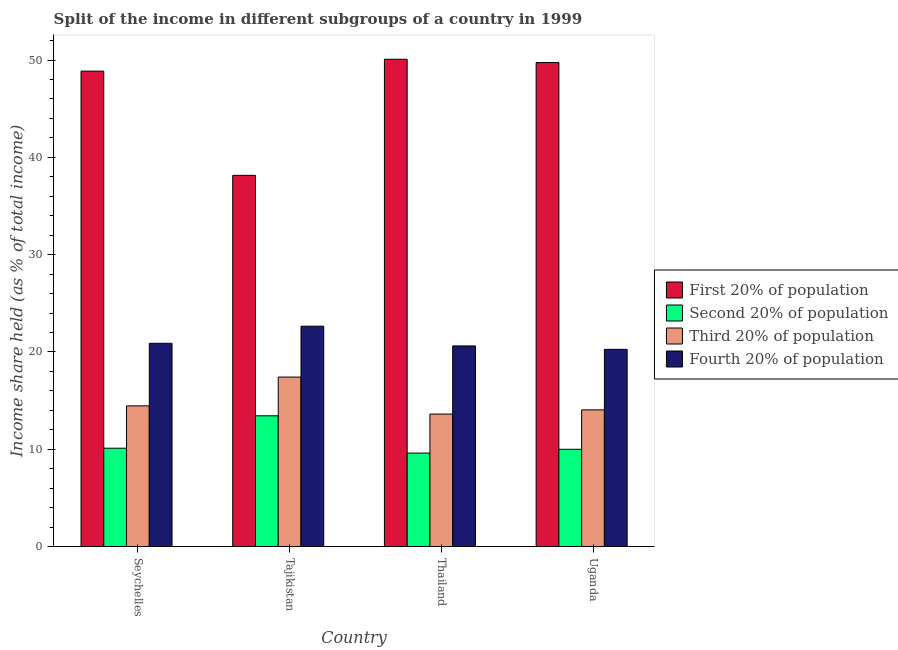Are the number of bars per tick equal to the number of legend labels?
Provide a short and direct response. Yes. Are the number of bars on each tick of the X-axis equal?
Provide a succinct answer. Yes. How many bars are there on the 2nd tick from the left?
Your answer should be very brief. 4. What is the label of the 2nd group of bars from the left?
Give a very brief answer. Tajikistan. In how many cases, is the number of bars for a given country not equal to the number of legend labels?
Offer a terse response. 0. What is the share of the income held by second 20% of the population in Thailand?
Ensure brevity in your answer.  9.61. Across all countries, what is the maximum share of the income held by third 20% of the population?
Provide a short and direct response. 17.42. Across all countries, what is the minimum share of the income held by third 20% of the population?
Ensure brevity in your answer.  13.62. In which country was the share of the income held by third 20% of the population maximum?
Keep it short and to the point. Tajikistan. In which country was the share of the income held by fourth 20% of the population minimum?
Your response must be concise. Uganda. What is the total share of the income held by first 20% of the population in the graph?
Ensure brevity in your answer.  186.83. What is the difference between the share of the income held by second 20% of the population in Thailand and that in Uganda?
Provide a succinct answer. -0.39. What is the difference between the share of the income held by fourth 20% of the population in Seychelles and the share of the income held by third 20% of the population in Uganda?
Keep it short and to the point. 6.84. What is the average share of the income held by fourth 20% of the population per country?
Offer a very short reply. 21.11. What is the difference between the share of the income held by fourth 20% of the population and share of the income held by second 20% of the population in Tajikistan?
Offer a terse response. 9.21. What is the ratio of the share of the income held by fourth 20% of the population in Tajikistan to that in Uganda?
Offer a terse response. 1.12. What is the difference between the highest and the second highest share of the income held by second 20% of the population?
Your answer should be very brief. 3.33. What is the difference between the highest and the lowest share of the income held by second 20% of the population?
Offer a terse response. 3.83. In how many countries, is the share of the income held by second 20% of the population greater than the average share of the income held by second 20% of the population taken over all countries?
Your response must be concise. 1. Is the sum of the share of the income held by second 20% of the population in Thailand and Uganda greater than the maximum share of the income held by first 20% of the population across all countries?
Make the answer very short. No. Is it the case that in every country, the sum of the share of the income held by fourth 20% of the population and share of the income held by third 20% of the population is greater than the sum of share of the income held by first 20% of the population and share of the income held by second 20% of the population?
Make the answer very short. No. What does the 1st bar from the left in Seychelles represents?
Provide a short and direct response. First 20% of population. What does the 4th bar from the right in Thailand represents?
Offer a very short reply. First 20% of population. How many bars are there?
Give a very brief answer. 16. What is the difference between two consecutive major ticks on the Y-axis?
Make the answer very short. 10. Does the graph contain grids?
Offer a very short reply. No. Where does the legend appear in the graph?
Your answer should be very brief. Center right. How many legend labels are there?
Provide a succinct answer. 4. What is the title of the graph?
Your response must be concise. Split of the income in different subgroups of a country in 1999. What is the label or title of the Y-axis?
Offer a very short reply. Income share held (as % of total income). What is the Income share held (as % of total income) of First 20% of population in Seychelles?
Your response must be concise. 48.86. What is the Income share held (as % of total income) of Second 20% of population in Seychelles?
Make the answer very short. 10.11. What is the Income share held (as % of total income) in Third 20% of population in Seychelles?
Offer a terse response. 14.46. What is the Income share held (as % of total income) of Fourth 20% of population in Seychelles?
Offer a terse response. 20.89. What is the Income share held (as % of total income) of First 20% of population in Tajikistan?
Provide a short and direct response. 38.15. What is the Income share held (as % of total income) of Second 20% of population in Tajikistan?
Offer a very short reply. 13.44. What is the Income share held (as % of total income) in Third 20% of population in Tajikistan?
Your response must be concise. 17.42. What is the Income share held (as % of total income) in Fourth 20% of population in Tajikistan?
Your answer should be compact. 22.65. What is the Income share held (as % of total income) in First 20% of population in Thailand?
Keep it short and to the point. 50.08. What is the Income share held (as % of total income) in Second 20% of population in Thailand?
Offer a terse response. 9.61. What is the Income share held (as % of total income) in Third 20% of population in Thailand?
Give a very brief answer. 13.62. What is the Income share held (as % of total income) in Fourth 20% of population in Thailand?
Make the answer very short. 20.62. What is the Income share held (as % of total income) in First 20% of population in Uganda?
Provide a succinct answer. 49.74. What is the Income share held (as % of total income) in Third 20% of population in Uganda?
Your response must be concise. 14.05. What is the Income share held (as % of total income) in Fourth 20% of population in Uganda?
Offer a terse response. 20.27. Across all countries, what is the maximum Income share held (as % of total income) in First 20% of population?
Your answer should be very brief. 50.08. Across all countries, what is the maximum Income share held (as % of total income) of Second 20% of population?
Make the answer very short. 13.44. Across all countries, what is the maximum Income share held (as % of total income) in Third 20% of population?
Make the answer very short. 17.42. Across all countries, what is the maximum Income share held (as % of total income) in Fourth 20% of population?
Offer a terse response. 22.65. Across all countries, what is the minimum Income share held (as % of total income) of First 20% of population?
Your answer should be very brief. 38.15. Across all countries, what is the minimum Income share held (as % of total income) of Second 20% of population?
Ensure brevity in your answer.  9.61. Across all countries, what is the minimum Income share held (as % of total income) in Third 20% of population?
Your response must be concise. 13.62. Across all countries, what is the minimum Income share held (as % of total income) of Fourth 20% of population?
Make the answer very short. 20.27. What is the total Income share held (as % of total income) of First 20% of population in the graph?
Ensure brevity in your answer.  186.83. What is the total Income share held (as % of total income) of Second 20% of population in the graph?
Provide a short and direct response. 43.16. What is the total Income share held (as % of total income) of Third 20% of population in the graph?
Your answer should be very brief. 59.55. What is the total Income share held (as % of total income) in Fourth 20% of population in the graph?
Your answer should be compact. 84.43. What is the difference between the Income share held (as % of total income) of First 20% of population in Seychelles and that in Tajikistan?
Provide a short and direct response. 10.71. What is the difference between the Income share held (as % of total income) of Second 20% of population in Seychelles and that in Tajikistan?
Offer a terse response. -3.33. What is the difference between the Income share held (as % of total income) of Third 20% of population in Seychelles and that in Tajikistan?
Provide a short and direct response. -2.96. What is the difference between the Income share held (as % of total income) of Fourth 20% of population in Seychelles and that in Tajikistan?
Your response must be concise. -1.76. What is the difference between the Income share held (as % of total income) in First 20% of population in Seychelles and that in Thailand?
Ensure brevity in your answer.  -1.22. What is the difference between the Income share held (as % of total income) of Second 20% of population in Seychelles and that in Thailand?
Your response must be concise. 0.5. What is the difference between the Income share held (as % of total income) of Third 20% of population in Seychelles and that in Thailand?
Your answer should be very brief. 0.84. What is the difference between the Income share held (as % of total income) in Fourth 20% of population in Seychelles and that in Thailand?
Offer a very short reply. 0.27. What is the difference between the Income share held (as % of total income) of First 20% of population in Seychelles and that in Uganda?
Your answer should be very brief. -0.88. What is the difference between the Income share held (as % of total income) of Second 20% of population in Seychelles and that in Uganda?
Give a very brief answer. 0.11. What is the difference between the Income share held (as % of total income) in Third 20% of population in Seychelles and that in Uganda?
Provide a succinct answer. 0.41. What is the difference between the Income share held (as % of total income) in Fourth 20% of population in Seychelles and that in Uganda?
Provide a succinct answer. 0.62. What is the difference between the Income share held (as % of total income) of First 20% of population in Tajikistan and that in Thailand?
Offer a very short reply. -11.93. What is the difference between the Income share held (as % of total income) in Second 20% of population in Tajikistan and that in Thailand?
Your answer should be very brief. 3.83. What is the difference between the Income share held (as % of total income) of Fourth 20% of population in Tajikistan and that in Thailand?
Your response must be concise. 2.03. What is the difference between the Income share held (as % of total income) in First 20% of population in Tajikistan and that in Uganda?
Make the answer very short. -11.59. What is the difference between the Income share held (as % of total income) in Second 20% of population in Tajikistan and that in Uganda?
Ensure brevity in your answer.  3.44. What is the difference between the Income share held (as % of total income) in Third 20% of population in Tajikistan and that in Uganda?
Ensure brevity in your answer.  3.37. What is the difference between the Income share held (as % of total income) of Fourth 20% of population in Tajikistan and that in Uganda?
Provide a short and direct response. 2.38. What is the difference between the Income share held (as % of total income) in First 20% of population in Thailand and that in Uganda?
Keep it short and to the point. 0.34. What is the difference between the Income share held (as % of total income) of Second 20% of population in Thailand and that in Uganda?
Offer a very short reply. -0.39. What is the difference between the Income share held (as % of total income) in Third 20% of population in Thailand and that in Uganda?
Give a very brief answer. -0.43. What is the difference between the Income share held (as % of total income) in First 20% of population in Seychelles and the Income share held (as % of total income) in Second 20% of population in Tajikistan?
Your answer should be very brief. 35.42. What is the difference between the Income share held (as % of total income) in First 20% of population in Seychelles and the Income share held (as % of total income) in Third 20% of population in Tajikistan?
Ensure brevity in your answer.  31.44. What is the difference between the Income share held (as % of total income) in First 20% of population in Seychelles and the Income share held (as % of total income) in Fourth 20% of population in Tajikistan?
Keep it short and to the point. 26.21. What is the difference between the Income share held (as % of total income) in Second 20% of population in Seychelles and the Income share held (as % of total income) in Third 20% of population in Tajikistan?
Provide a succinct answer. -7.31. What is the difference between the Income share held (as % of total income) of Second 20% of population in Seychelles and the Income share held (as % of total income) of Fourth 20% of population in Tajikistan?
Your answer should be compact. -12.54. What is the difference between the Income share held (as % of total income) of Third 20% of population in Seychelles and the Income share held (as % of total income) of Fourth 20% of population in Tajikistan?
Keep it short and to the point. -8.19. What is the difference between the Income share held (as % of total income) of First 20% of population in Seychelles and the Income share held (as % of total income) of Second 20% of population in Thailand?
Make the answer very short. 39.25. What is the difference between the Income share held (as % of total income) of First 20% of population in Seychelles and the Income share held (as % of total income) of Third 20% of population in Thailand?
Your answer should be compact. 35.24. What is the difference between the Income share held (as % of total income) of First 20% of population in Seychelles and the Income share held (as % of total income) of Fourth 20% of population in Thailand?
Your response must be concise. 28.24. What is the difference between the Income share held (as % of total income) of Second 20% of population in Seychelles and the Income share held (as % of total income) of Third 20% of population in Thailand?
Offer a terse response. -3.51. What is the difference between the Income share held (as % of total income) in Second 20% of population in Seychelles and the Income share held (as % of total income) in Fourth 20% of population in Thailand?
Keep it short and to the point. -10.51. What is the difference between the Income share held (as % of total income) in Third 20% of population in Seychelles and the Income share held (as % of total income) in Fourth 20% of population in Thailand?
Offer a very short reply. -6.16. What is the difference between the Income share held (as % of total income) of First 20% of population in Seychelles and the Income share held (as % of total income) of Second 20% of population in Uganda?
Give a very brief answer. 38.86. What is the difference between the Income share held (as % of total income) in First 20% of population in Seychelles and the Income share held (as % of total income) in Third 20% of population in Uganda?
Your answer should be compact. 34.81. What is the difference between the Income share held (as % of total income) of First 20% of population in Seychelles and the Income share held (as % of total income) of Fourth 20% of population in Uganda?
Your response must be concise. 28.59. What is the difference between the Income share held (as % of total income) in Second 20% of population in Seychelles and the Income share held (as % of total income) in Third 20% of population in Uganda?
Your answer should be very brief. -3.94. What is the difference between the Income share held (as % of total income) of Second 20% of population in Seychelles and the Income share held (as % of total income) of Fourth 20% of population in Uganda?
Ensure brevity in your answer.  -10.16. What is the difference between the Income share held (as % of total income) of Third 20% of population in Seychelles and the Income share held (as % of total income) of Fourth 20% of population in Uganda?
Make the answer very short. -5.81. What is the difference between the Income share held (as % of total income) in First 20% of population in Tajikistan and the Income share held (as % of total income) in Second 20% of population in Thailand?
Your answer should be very brief. 28.54. What is the difference between the Income share held (as % of total income) in First 20% of population in Tajikistan and the Income share held (as % of total income) in Third 20% of population in Thailand?
Make the answer very short. 24.53. What is the difference between the Income share held (as % of total income) of First 20% of population in Tajikistan and the Income share held (as % of total income) of Fourth 20% of population in Thailand?
Your answer should be compact. 17.53. What is the difference between the Income share held (as % of total income) of Second 20% of population in Tajikistan and the Income share held (as % of total income) of Third 20% of population in Thailand?
Keep it short and to the point. -0.18. What is the difference between the Income share held (as % of total income) of Second 20% of population in Tajikistan and the Income share held (as % of total income) of Fourth 20% of population in Thailand?
Provide a succinct answer. -7.18. What is the difference between the Income share held (as % of total income) of First 20% of population in Tajikistan and the Income share held (as % of total income) of Second 20% of population in Uganda?
Your answer should be very brief. 28.15. What is the difference between the Income share held (as % of total income) of First 20% of population in Tajikistan and the Income share held (as % of total income) of Third 20% of population in Uganda?
Give a very brief answer. 24.1. What is the difference between the Income share held (as % of total income) of First 20% of population in Tajikistan and the Income share held (as % of total income) of Fourth 20% of population in Uganda?
Your answer should be compact. 17.88. What is the difference between the Income share held (as % of total income) in Second 20% of population in Tajikistan and the Income share held (as % of total income) in Third 20% of population in Uganda?
Your answer should be very brief. -0.61. What is the difference between the Income share held (as % of total income) in Second 20% of population in Tajikistan and the Income share held (as % of total income) in Fourth 20% of population in Uganda?
Your answer should be compact. -6.83. What is the difference between the Income share held (as % of total income) in Third 20% of population in Tajikistan and the Income share held (as % of total income) in Fourth 20% of population in Uganda?
Your answer should be very brief. -2.85. What is the difference between the Income share held (as % of total income) of First 20% of population in Thailand and the Income share held (as % of total income) of Second 20% of population in Uganda?
Offer a very short reply. 40.08. What is the difference between the Income share held (as % of total income) of First 20% of population in Thailand and the Income share held (as % of total income) of Third 20% of population in Uganda?
Offer a very short reply. 36.03. What is the difference between the Income share held (as % of total income) in First 20% of population in Thailand and the Income share held (as % of total income) in Fourth 20% of population in Uganda?
Provide a short and direct response. 29.81. What is the difference between the Income share held (as % of total income) of Second 20% of population in Thailand and the Income share held (as % of total income) of Third 20% of population in Uganda?
Your answer should be very brief. -4.44. What is the difference between the Income share held (as % of total income) in Second 20% of population in Thailand and the Income share held (as % of total income) in Fourth 20% of population in Uganda?
Your answer should be compact. -10.66. What is the difference between the Income share held (as % of total income) in Third 20% of population in Thailand and the Income share held (as % of total income) in Fourth 20% of population in Uganda?
Your answer should be very brief. -6.65. What is the average Income share held (as % of total income) in First 20% of population per country?
Give a very brief answer. 46.71. What is the average Income share held (as % of total income) in Second 20% of population per country?
Your answer should be very brief. 10.79. What is the average Income share held (as % of total income) of Third 20% of population per country?
Provide a succinct answer. 14.89. What is the average Income share held (as % of total income) in Fourth 20% of population per country?
Give a very brief answer. 21.11. What is the difference between the Income share held (as % of total income) of First 20% of population and Income share held (as % of total income) of Second 20% of population in Seychelles?
Give a very brief answer. 38.75. What is the difference between the Income share held (as % of total income) of First 20% of population and Income share held (as % of total income) of Third 20% of population in Seychelles?
Your answer should be compact. 34.4. What is the difference between the Income share held (as % of total income) of First 20% of population and Income share held (as % of total income) of Fourth 20% of population in Seychelles?
Your response must be concise. 27.97. What is the difference between the Income share held (as % of total income) in Second 20% of population and Income share held (as % of total income) in Third 20% of population in Seychelles?
Your answer should be very brief. -4.35. What is the difference between the Income share held (as % of total income) in Second 20% of population and Income share held (as % of total income) in Fourth 20% of population in Seychelles?
Your answer should be very brief. -10.78. What is the difference between the Income share held (as % of total income) in Third 20% of population and Income share held (as % of total income) in Fourth 20% of population in Seychelles?
Ensure brevity in your answer.  -6.43. What is the difference between the Income share held (as % of total income) in First 20% of population and Income share held (as % of total income) in Second 20% of population in Tajikistan?
Your answer should be compact. 24.71. What is the difference between the Income share held (as % of total income) in First 20% of population and Income share held (as % of total income) in Third 20% of population in Tajikistan?
Offer a terse response. 20.73. What is the difference between the Income share held (as % of total income) of First 20% of population and Income share held (as % of total income) of Fourth 20% of population in Tajikistan?
Keep it short and to the point. 15.5. What is the difference between the Income share held (as % of total income) of Second 20% of population and Income share held (as % of total income) of Third 20% of population in Tajikistan?
Your response must be concise. -3.98. What is the difference between the Income share held (as % of total income) in Second 20% of population and Income share held (as % of total income) in Fourth 20% of population in Tajikistan?
Give a very brief answer. -9.21. What is the difference between the Income share held (as % of total income) of Third 20% of population and Income share held (as % of total income) of Fourth 20% of population in Tajikistan?
Your answer should be very brief. -5.23. What is the difference between the Income share held (as % of total income) in First 20% of population and Income share held (as % of total income) in Second 20% of population in Thailand?
Your answer should be very brief. 40.47. What is the difference between the Income share held (as % of total income) in First 20% of population and Income share held (as % of total income) in Third 20% of population in Thailand?
Your response must be concise. 36.46. What is the difference between the Income share held (as % of total income) of First 20% of population and Income share held (as % of total income) of Fourth 20% of population in Thailand?
Offer a very short reply. 29.46. What is the difference between the Income share held (as % of total income) of Second 20% of population and Income share held (as % of total income) of Third 20% of population in Thailand?
Your answer should be very brief. -4.01. What is the difference between the Income share held (as % of total income) in Second 20% of population and Income share held (as % of total income) in Fourth 20% of population in Thailand?
Offer a very short reply. -11.01. What is the difference between the Income share held (as % of total income) in Third 20% of population and Income share held (as % of total income) in Fourth 20% of population in Thailand?
Give a very brief answer. -7. What is the difference between the Income share held (as % of total income) of First 20% of population and Income share held (as % of total income) of Second 20% of population in Uganda?
Make the answer very short. 39.74. What is the difference between the Income share held (as % of total income) in First 20% of population and Income share held (as % of total income) in Third 20% of population in Uganda?
Offer a very short reply. 35.69. What is the difference between the Income share held (as % of total income) of First 20% of population and Income share held (as % of total income) of Fourth 20% of population in Uganda?
Your answer should be compact. 29.47. What is the difference between the Income share held (as % of total income) of Second 20% of population and Income share held (as % of total income) of Third 20% of population in Uganda?
Offer a very short reply. -4.05. What is the difference between the Income share held (as % of total income) in Second 20% of population and Income share held (as % of total income) in Fourth 20% of population in Uganda?
Make the answer very short. -10.27. What is the difference between the Income share held (as % of total income) of Third 20% of population and Income share held (as % of total income) of Fourth 20% of population in Uganda?
Make the answer very short. -6.22. What is the ratio of the Income share held (as % of total income) of First 20% of population in Seychelles to that in Tajikistan?
Offer a very short reply. 1.28. What is the ratio of the Income share held (as % of total income) of Second 20% of population in Seychelles to that in Tajikistan?
Your answer should be very brief. 0.75. What is the ratio of the Income share held (as % of total income) in Third 20% of population in Seychelles to that in Tajikistan?
Offer a terse response. 0.83. What is the ratio of the Income share held (as % of total income) of Fourth 20% of population in Seychelles to that in Tajikistan?
Your answer should be compact. 0.92. What is the ratio of the Income share held (as % of total income) in First 20% of population in Seychelles to that in Thailand?
Make the answer very short. 0.98. What is the ratio of the Income share held (as % of total income) of Second 20% of population in Seychelles to that in Thailand?
Your answer should be compact. 1.05. What is the ratio of the Income share held (as % of total income) in Third 20% of population in Seychelles to that in Thailand?
Give a very brief answer. 1.06. What is the ratio of the Income share held (as % of total income) of Fourth 20% of population in Seychelles to that in Thailand?
Provide a succinct answer. 1.01. What is the ratio of the Income share held (as % of total income) in First 20% of population in Seychelles to that in Uganda?
Your answer should be very brief. 0.98. What is the ratio of the Income share held (as % of total income) of Third 20% of population in Seychelles to that in Uganda?
Give a very brief answer. 1.03. What is the ratio of the Income share held (as % of total income) in Fourth 20% of population in Seychelles to that in Uganda?
Keep it short and to the point. 1.03. What is the ratio of the Income share held (as % of total income) in First 20% of population in Tajikistan to that in Thailand?
Give a very brief answer. 0.76. What is the ratio of the Income share held (as % of total income) of Second 20% of population in Tajikistan to that in Thailand?
Provide a succinct answer. 1.4. What is the ratio of the Income share held (as % of total income) of Third 20% of population in Tajikistan to that in Thailand?
Ensure brevity in your answer.  1.28. What is the ratio of the Income share held (as % of total income) in Fourth 20% of population in Tajikistan to that in Thailand?
Give a very brief answer. 1.1. What is the ratio of the Income share held (as % of total income) in First 20% of population in Tajikistan to that in Uganda?
Provide a succinct answer. 0.77. What is the ratio of the Income share held (as % of total income) in Second 20% of population in Tajikistan to that in Uganda?
Your answer should be compact. 1.34. What is the ratio of the Income share held (as % of total income) in Third 20% of population in Tajikistan to that in Uganda?
Your answer should be compact. 1.24. What is the ratio of the Income share held (as % of total income) in Fourth 20% of population in Tajikistan to that in Uganda?
Ensure brevity in your answer.  1.12. What is the ratio of the Income share held (as % of total income) in First 20% of population in Thailand to that in Uganda?
Provide a succinct answer. 1.01. What is the ratio of the Income share held (as % of total income) in Second 20% of population in Thailand to that in Uganda?
Your response must be concise. 0.96. What is the ratio of the Income share held (as % of total income) in Third 20% of population in Thailand to that in Uganda?
Provide a succinct answer. 0.97. What is the ratio of the Income share held (as % of total income) of Fourth 20% of population in Thailand to that in Uganda?
Your answer should be very brief. 1.02. What is the difference between the highest and the second highest Income share held (as % of total income) in First 20% of population?
Provide a short and direct response. 0.34. What is the difference between the highest and the second highest Income share held (as % of total income) of Second 20% of population?
Make the answer very short. 3.33. What is the difference between the highest and the second highest Income share held (as % of total income) of Third 20% of population?
Your response must be concise. 2.96. What is the difference between the highest and the second highest Income share held (as % of total income) in Fourth 20% of population?
Offer a terse response. 1.76. What is the difference between the highest and the lowest Income share held (as % of total income) in First 20% of population?
Your response must be concise. 11.93. What is the difference between the highest and the lowest Income share held (as % of total income) in Second 20% of population?
Keep it short and to the point. 3.83. What is the difference between the highest and the lowest Income share held (as % of total income) in Third 20% of population?
Offer a terse response. 3.8. What is the difference between the highest and the lowest Income share held (as % of total income) of Fourth 20% of population?
Provide a succinct answer. 2.38. 